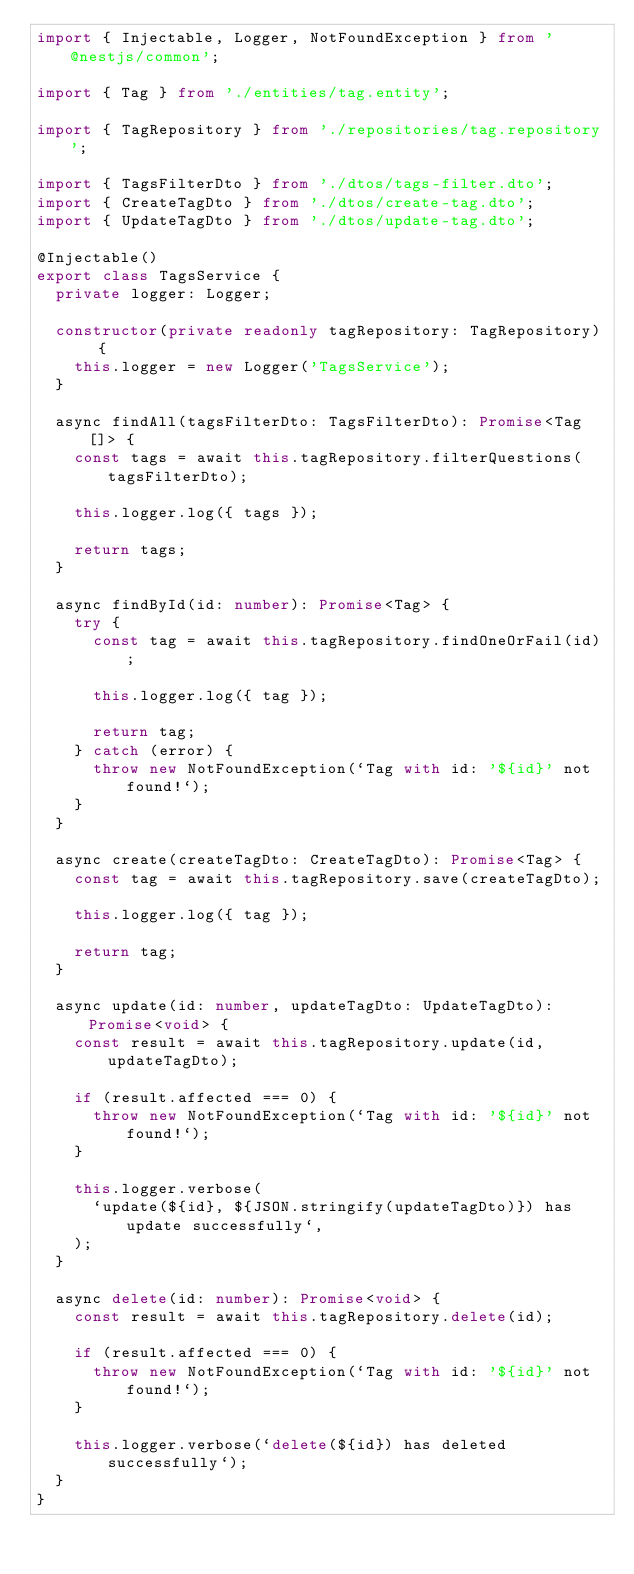<code> <loc_0><loc_0><loc_500><loc_500><_TypeScript_>import { Injectable, Logger, NotFoundException } from '@nestjs/common';

import { Tag } from './entities/tag.entity';

import { TagRepository } from './repositories/tag.repository';

import { TagsFilterDto } from './dtos/tags-filter.dto';
import { CreateTagDto } from './dtos/create-tag.dto';
import { UpdateTagDto } from './dtos/update-tag.dto';

@Injectable()
export class TagsService {
  private logger: Logger;

  constructor(private readonly tagRepository: TagRepository) {
    this.logger = new Logger('TagsService');
  }

  async findAll(tagsFilterDto: TagsFilterDto): Promise<Tag[]> {
    const tags = await this.tagRepository.filterQuestions(tagsFilterDto);

    this.logger.log({ tags });

    return tags;
  }

  async findById(id: number): Promise<Tag> {
    try {
      const tag = await this.tagRepository.findOneOrFail(id);

      this.logger.log({ tag });

      return tag;
    } catch (error) {
      throw new NotFoundException(`Tag with id: '${id}' not found!`);
    }
  }

  async create(createTagDto: CreateTagDto): Promise<Tag> {
    const tag = await this.tagRepository.save(createTagDto);

    this.logger.log({ tag });

    return tag;
  }

  async update(id: number, updateTagDto: UpdateTagDto): Promise<void> {
    const result = await this.tagRepository.update(id, updateTagDto);

    if (result.affected === 0) {
      throw new NotFoundException(`Tag with id: '${id}' not found!`);
    }

    this.logger.verbose(
      `update(${id}, ${JSON.stringify(updateTagDto)}) has update successfully`,
    );
  }

  async delete(id: number): Promise<void> {
    const result = await this.tagRepository.delete(id);

    if (result.affected === 0) {
      throw new NotFoundException(`Tag with id: '${id}' not found!`);
    }

    this.logger.verbose(`delete(${id}) has deleted successfully`);
  }
}
</code> 